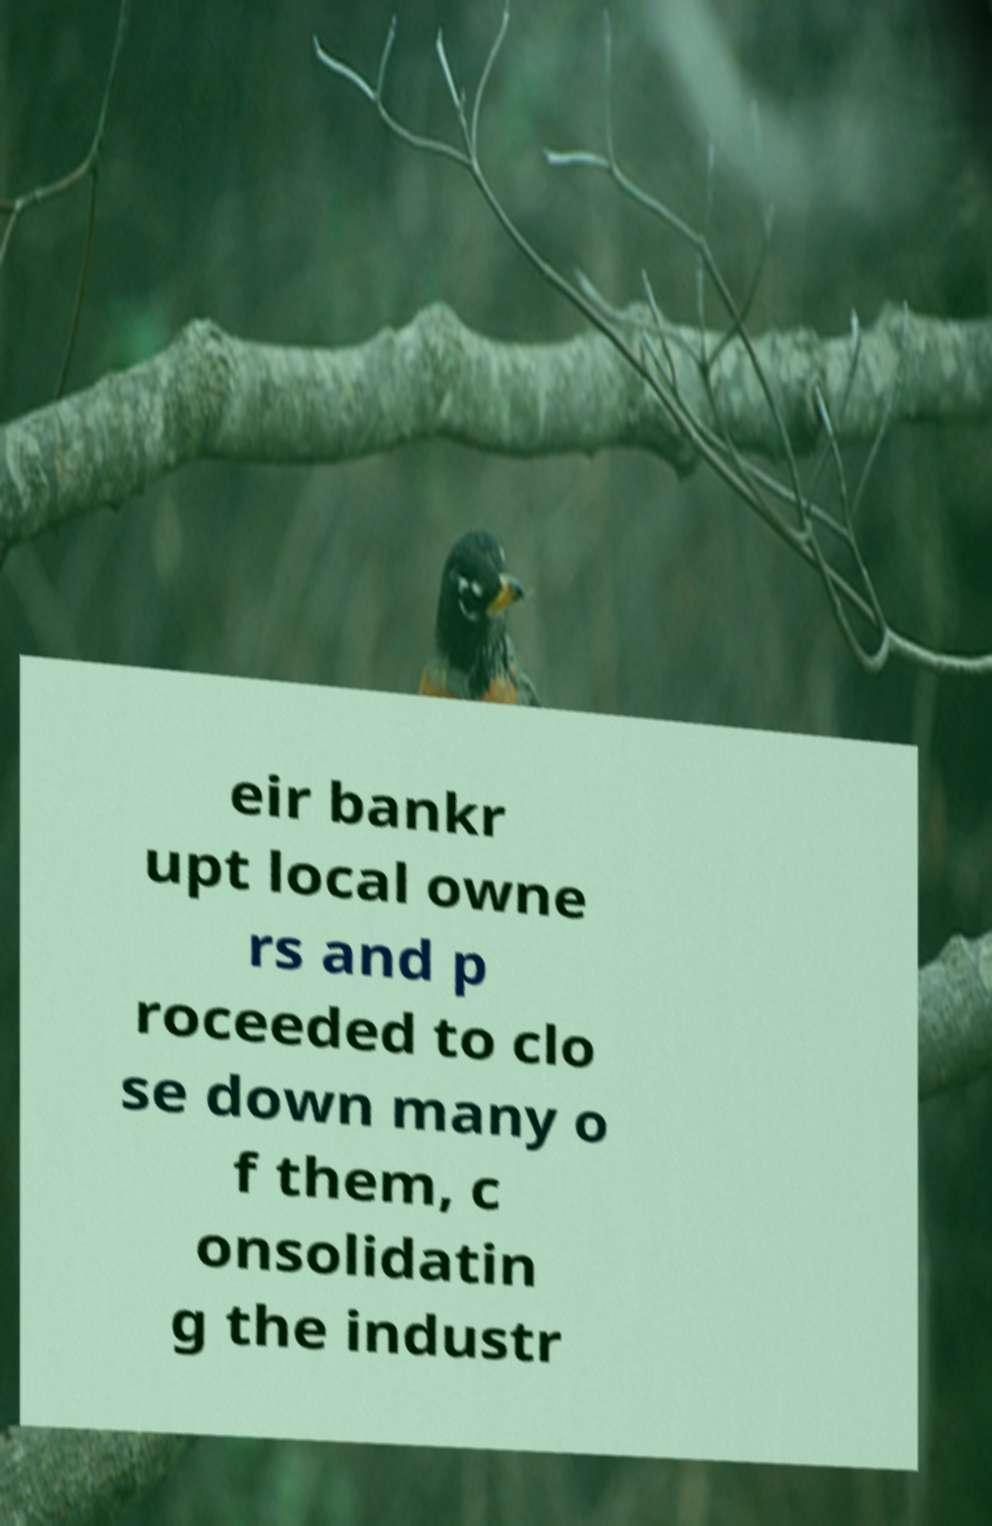For documentation purposes, I need the text within this image transcribed. Could you provide that? eir bankr upt local owne rs and p roceeded to clo se down many o f them, c onsolidatin g the industr 